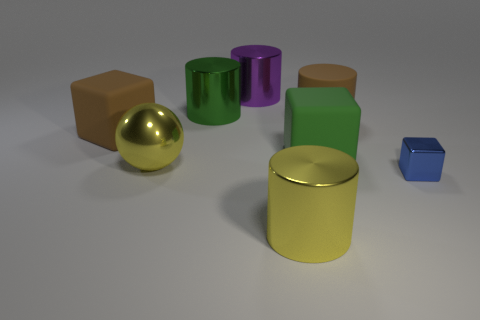Is there a big shiny ball?
Provide a short and direct response. Yes. Is the large green shiny object the same shape as the green rubber object?
Offer a very short reply. No. There is a shiny object that is the same color as the large metallic sphere; what size is it?
Give a very brief answer. Large. What number of metallic blocks are on the right side of the metallic cylinder on the right side of the purple metallic object?
Provide a short and direct response. 1. How many big things are behind the large yellow ball and on the left side of the green metallic cylinder?
Offer a very short reply. 1. How many objects are either blue matte spheres or yellow shiny things that are behind the tiny shiny cube?
Offer a terse response. 1. The green cylinder that is the same material as the purple cylinder is what size?
Provide a short and direct response. Large. The big yellow metal thing behind the shiny cylinder that is in front of the shiny ball is what shape?
Provide a succinct answer. Sphere. How many gray objects are cubes or large metal spheres?
Give a very brief answer. 0. There is a big yellow metallic thing to the right of the green object that is on the left side of the green rubber cube; is there a green matte block that is to the left of it?
Your answer should be very brief. No. 